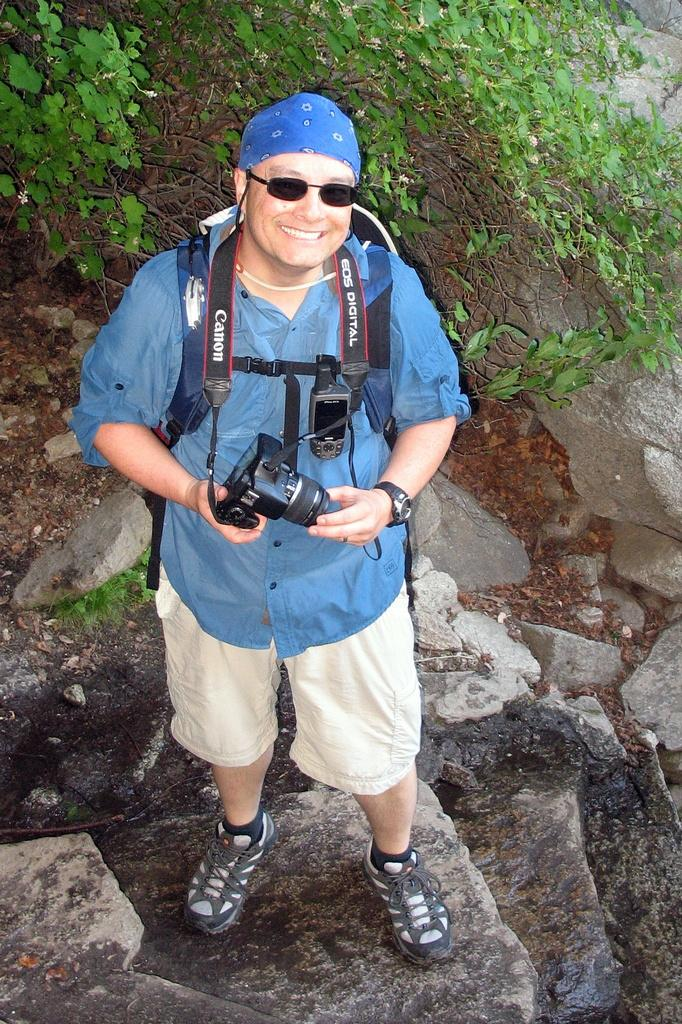What is the person in the image wearing on their upper body? The person is wearing a blue shirt. What type of eyewear is the person wearing? The person is wearing sunglasses. What type of lower-body clothing is the person wearing? The person is wearing gray shorts. What type of footwear is the person wearing? The person is wearing shoes. What is the person holding in the image? The person is holding a camera. What other item is visible in the image? There is a bag in the image. What can be seen in the background of the image? There are rocks and plants in the background of the image. How does the person in the image increase the amount of rice in the image? There is no rice present in the image, so it cannot be increased. 